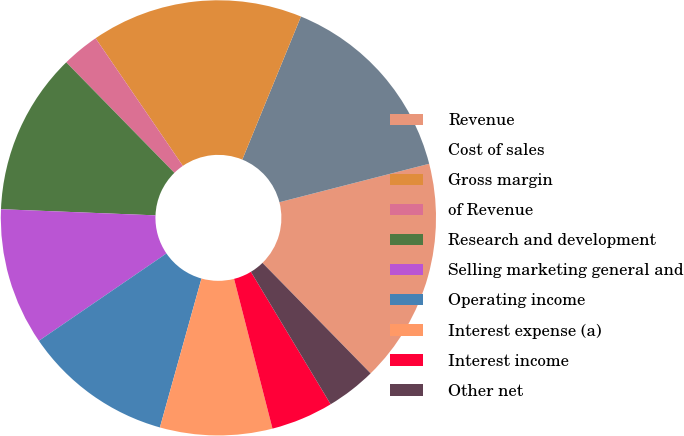Convert chart. <chart><loc_0><loc_0><loc_500><loc_500><pie_chart><fcel>Revenue<fcel>Cost of sales<fcel>Gross margin<fcel>of Revenue<fcel>Research and development<fcel>Selling marketing general and<fcel>Operating income<fcel>Interest expense (a)<fcel>Interest income<fcel>Other net<nl><fcel>16.67%<fcel>14.81%<fcel>15.74%<fcel>2.78%<fcel>12.04%<fcel>10.19%<fcel>11.11%<fcel>8.33%<fcel>4.63%<fcel>3.7%<nl></chart> 